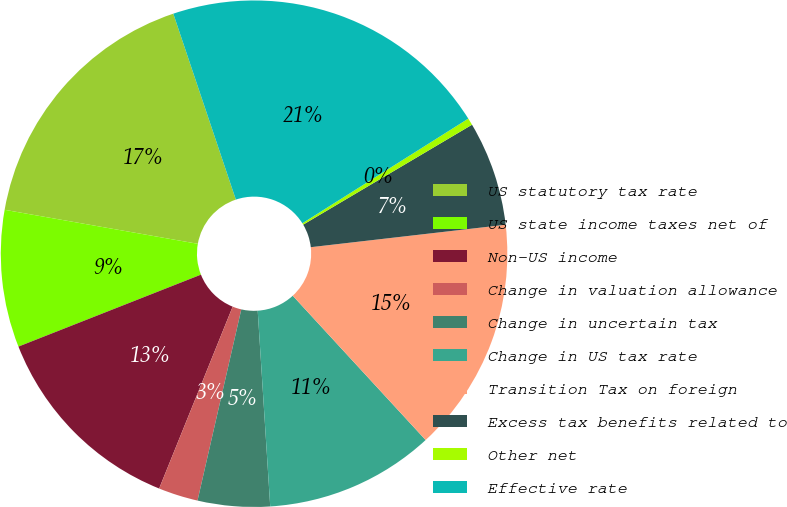Convert chart. <chart><loc_0><loc_0><loc_500><loc_500><pie_chart><fcel>US statutory tax rate<fcel>US state income taxes net of<fcel>Non-US income<fcel>Change in valuation allowance<fcel>Change in uncertain tax<fcel>Change in US tax rate<fcel>Transition Tax on foreign<fcel>Excess tax benefits related to<fcel>Other net<fcel>Effective rate<nl><fcel>17.06%<fcel>8.75%<fcel>12.91%<fcel>2.53%<fcel>4.6%<fcel>10.83%<fcel>14.98%<fcel>6.68%<fcel>0.45%<fcel>21.21%<nl></chart> 